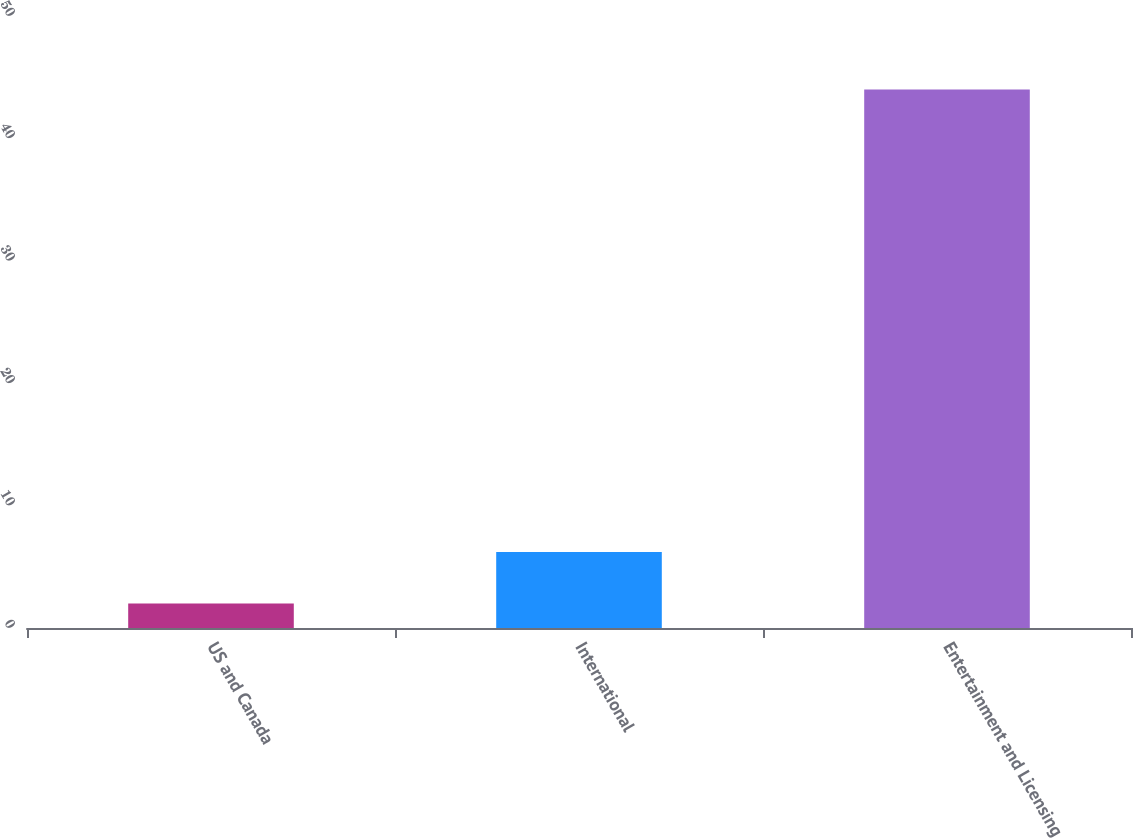Convert chart to OTSL. <chart><loc_0><loc_0><loc_500><loc_500><bar_chart><fcel>US and Canada<fcel>International<fcel>Entertainment and Licensing<nl><fcel>2<fcel>6.2<fcel>44<nl></chart> 